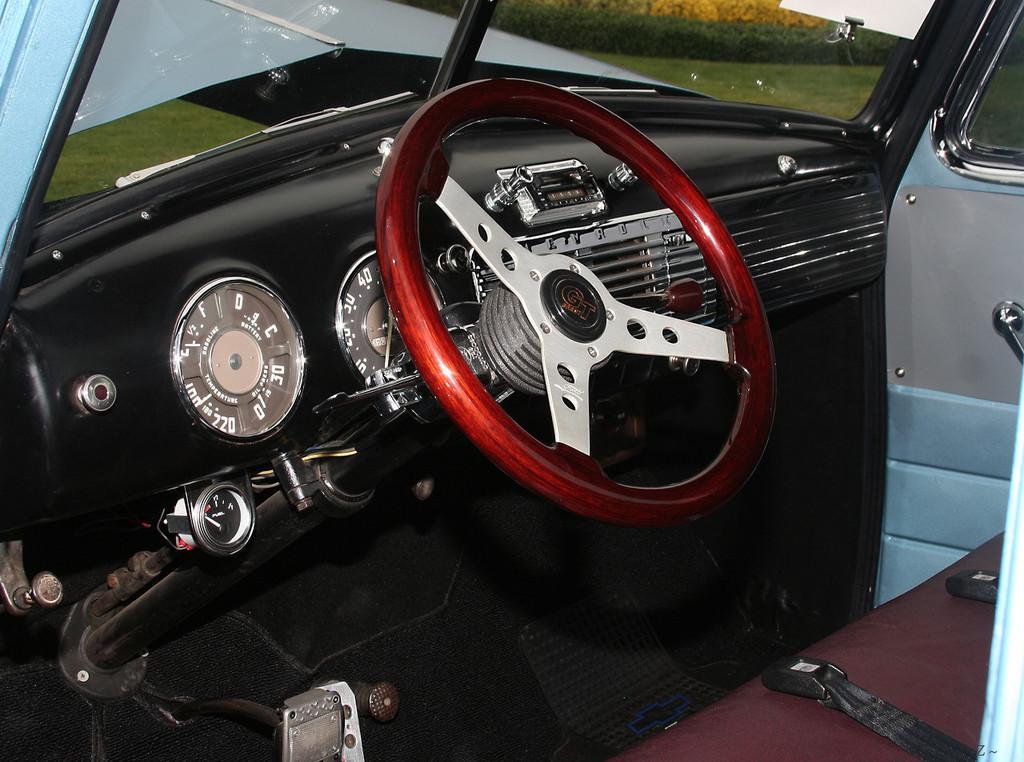Could you give a brief overview of what you see in this image? This is an inside view of a car. Here I can see the steering in red color. On the right side there is a seat. On the top I can see the glass. In the outside I can see the plants and grass. 